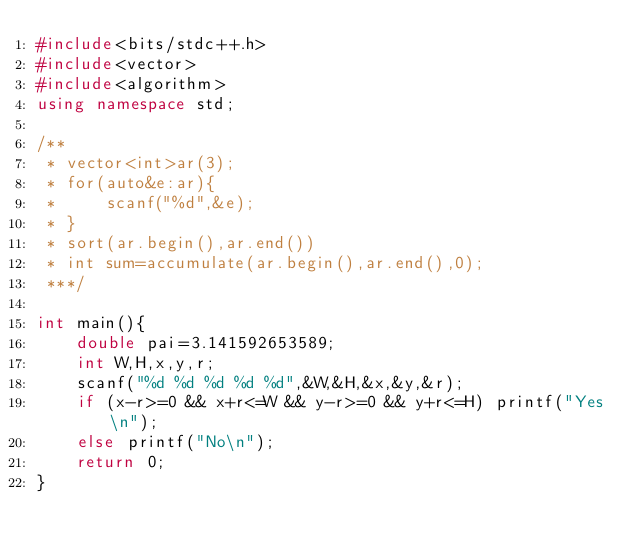<code> <loc_0><loc_0><loc_500><loc_500><_C++_>#include<bits/stdc++.h>
#include<vector>
#include<algorithm>
using namespace std;

/**
 * vector<int>ar(3);
 * for(auto&e:ar){
 *     scanf("%d",&e);
 * }
 * sort(ar.begin(),ar.end())
 * int sum=accumulate(ar.begin(),ar.end(),0);
 ***/

int main(){
    double pai=3.141592653589;
    int W,H,x,y,r;
    scanf("%d %d %d %d %d",&W,&H,&x,&y,&r);
    if (x-r>=0 && x+r<=W && y-r>=0 && y+r<=H) printf("Yes\n");
    else printf("No\n");
    return 0;
}</code> 